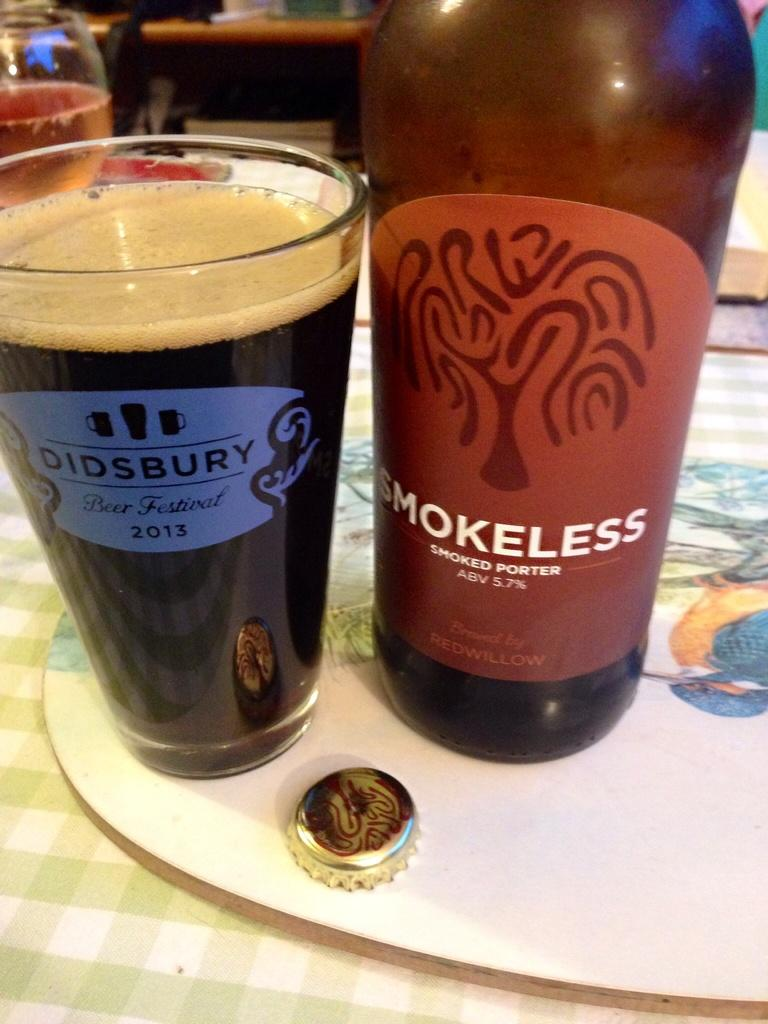<image>
Summarize the visual content of the image. A bottle of Smokeless smoked ported is next to a full glass that says Didsbury on it. 